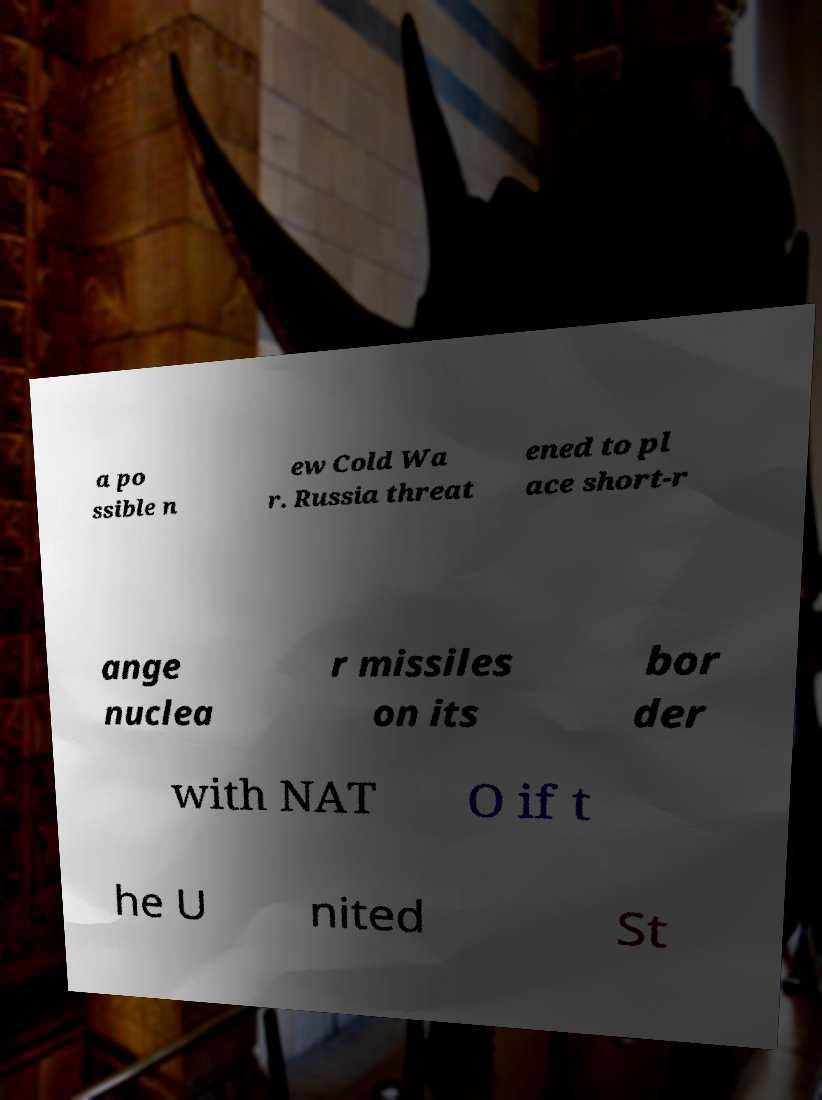For documentation purposes, I need the text within this image transcribed. Could you provide that? a po ssible n ew Cold Wa r. Russia threat ened to pl ace short-r ange nuclea r missiles on its bor der with NAT O if t he U nited St 